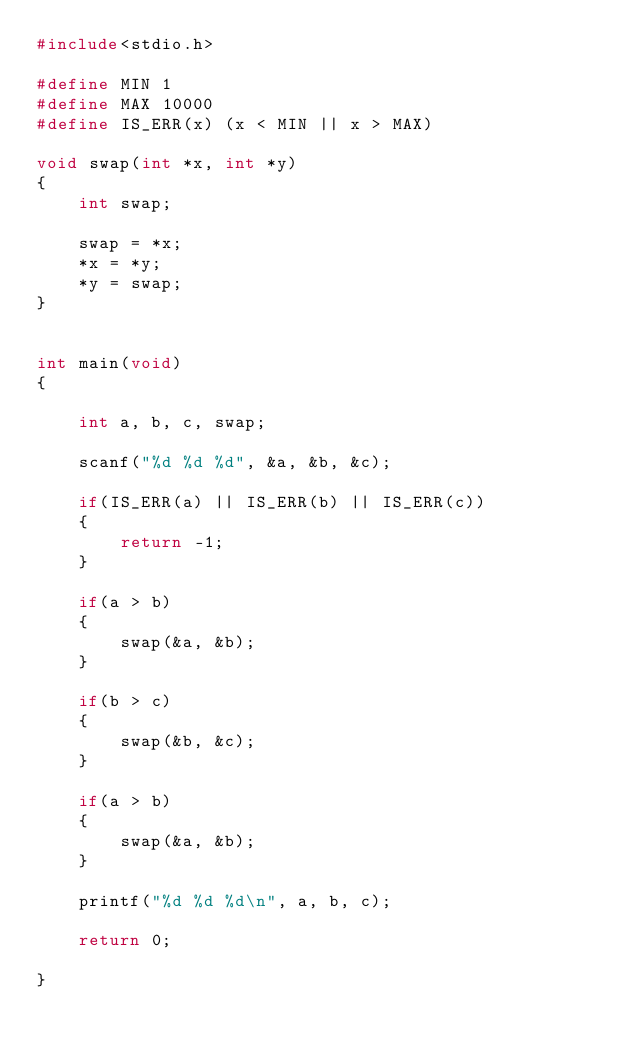Convert code to text. <code><loc_0><loc_0><loc_500><loc_500><_C_>#include<stdio.h>

#define MIN 1
#define MAX 10000
#define IS_ERR(x) (x < MIN || x > MAX)

void swap(int *x, int *y)
{
    int swap;

    swap = *x;
    *x = *y;
    *y = swap;
}


int main(void)
{

    int a, b, c, swap;

    scanf("%d %d %d", &a, &b, &c);

    if(IS_ERR(a) || IS_ERR(b) || IS_ERR(c))
    {
        return -1;
    }

    if(a > b)
    {
        swap(&a, &b);
    }

    if(b > c)
    {
        swap(&b, &c);
    }

    if(a > b)
    {
        swap(&a, &b);
    }        

    printf("%d %d %d\n", a, b, c);

    return 0;

}
</code> 